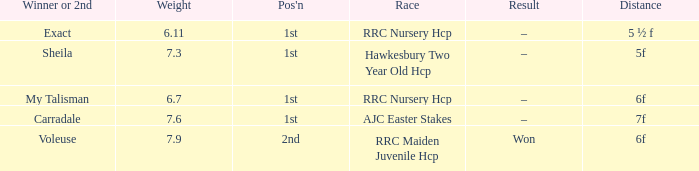What was the race when the winner of 2nd was Voleuse? RRC Maiden Juvenile Hcp. 